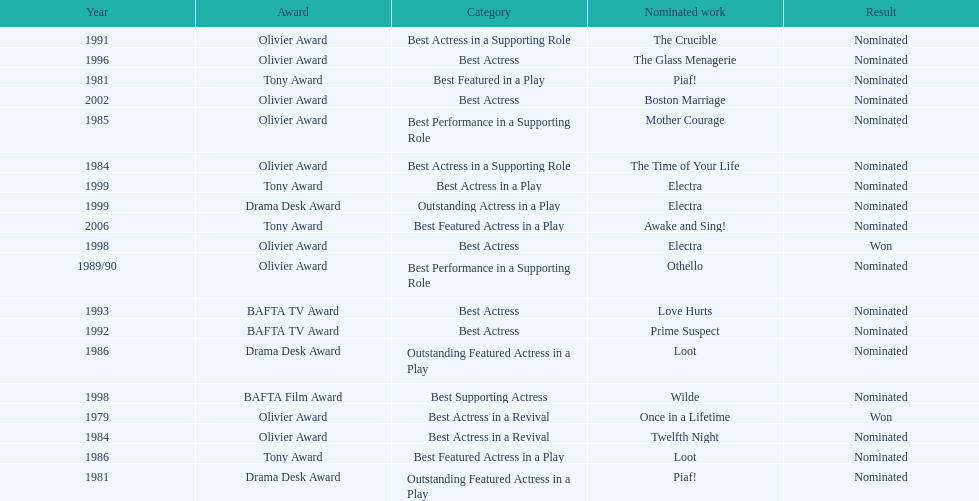Could you help me parse every detail presented in this table? {'header': ['Year', 'Award', 'Category', 'Nominated work', 'Result'], 'rows': [['1991', 'Olivier Award', 'Best Actress in a Supporting Role', 'The Crucible', 'Nominated'], ['1996', 'Olivier Award', 'Best Actress', 'The Glass Menagerie', 'Nominated'], ['1981', 'Tony Award', 'Best Featured in a Play', 'Piaf!', 'Nominated'], ['2002', 'Olivier Award', 'Best Actress', 'Boston Marriage', 'Nominated'], ['1985', 'Olivier Award', 'Best Performance in a Supporting Role', 'Mother Courage', 'Nominated'], ['1984', 'Olivier Award', 'Best Actress in a Supporting Role', 'The Time of Your Life', 'Nominated'], ['1999', 'Tony Award', 'Best Actress in a Play', 'Electra', 'Nominated'], ['1999', 'Drama Desk Award', 'Outstanding Actress in a Play', 'Electra', 'Nominated'], ['2006', 'Tony Award', 'Best Featured Actress in a Play', 'Awake and Sing!', 'Nominated'], ['1998', 'Olivier Award', 'Best Actress', 'Electra', 'Won'], ['1989/90', 'Olivier Award', 'Best Performance in a Supporting Role', 'Othello', 'Nominated'], ['1993', 'BAFTA TV Award', 'Best Actress', 'Love Hurts', 'Nominated'], ['1992', 'BAFTA TV Award', 'Best Actress', 'Prime Suspect', 'Nominated'], ['1986', 'Drama Desk Award', 'Outstanding Featured Actress in a Play', 'Loot', 'Nominated'], ['1998', 'BAFTA Film Award', 'Best Supporting Actress', 'Wilde', 'Nominated'], ['1979', 'Olivier Award', 'Best Actress in a Revival', 'Once in a Lifetime', 'Won'], ['1984', 'Olivier Award', 'Best Actress in a Revival', 'Twelfth Night', 'Nominated'], ['1986', 'Tony Award', 'Best Featured Actress in a Play', 'Loot', 'Nominated'], ['1981', 'Drama Desk Award', 'Outstanding Featured Actress in a Play', 'Piaf!', 'Nominated']]} What play was wanamaker nominated for best featured in a play in 1981? Piaf!. 